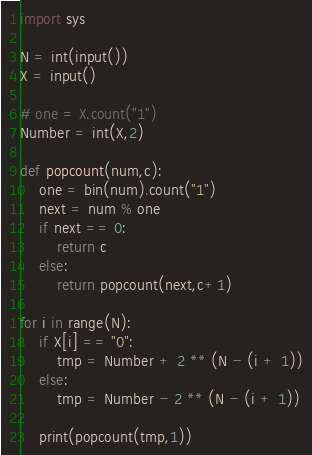<code> <loc_0><loc_0><loc_500><loc_500><_Python_>import sys

N = int(input())
X = input()

# one = X.count("1")
Number = int(X,2)

def popcount(num,c):
    one = bin(num).count("1")
    next = num % one
    if next == 0:
        return c
    else:
        return popcount(next,c+1)

for i in range(N):
    if X[i] == "0":
        tmp = Number + 2 ** (N - (i + 1))
    else:
        tmp = Number - 2 ** (N - (i + 1))
    
    print(popcount(tmp,1))
</code> 